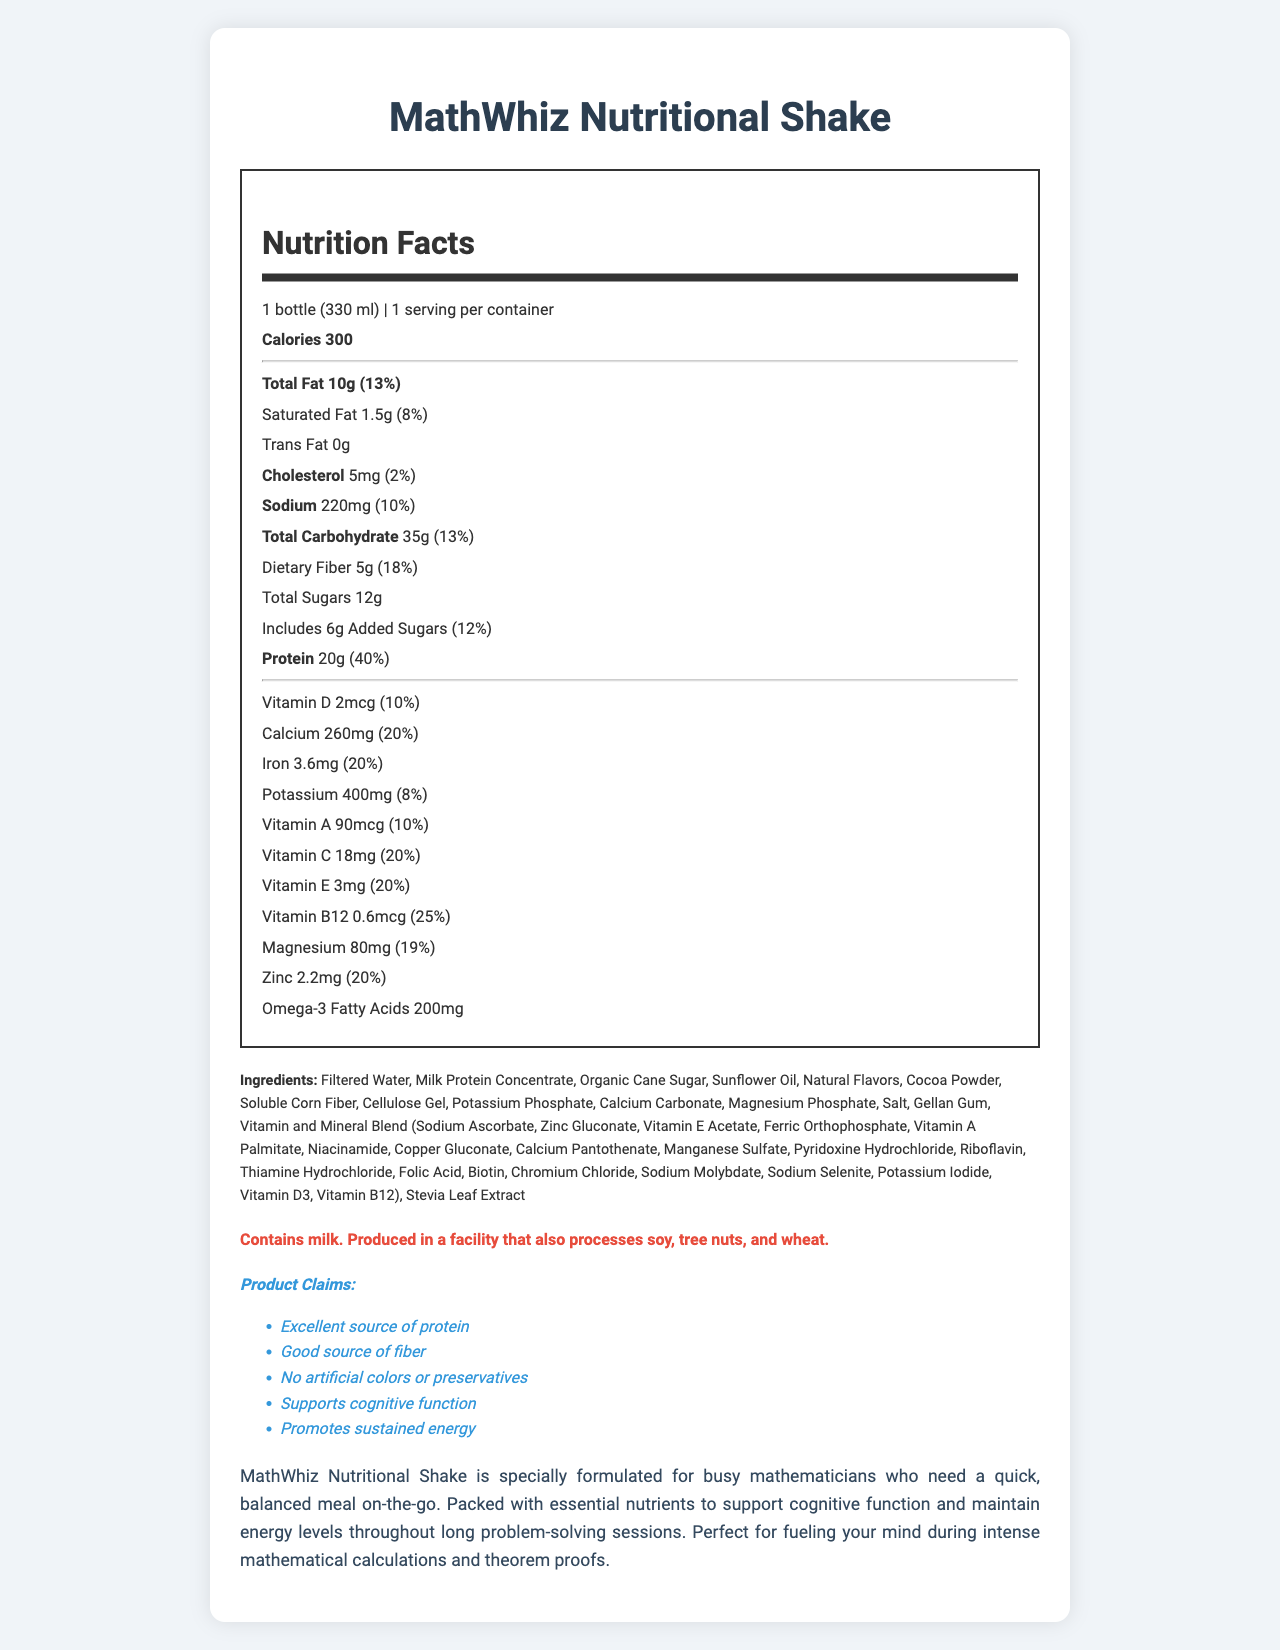what is the serving size of the MathWhiz Nutritional Shake? The serving size is clearly stated in the document as "1 bottle (330 ml)".
Answer: 1 bottle (330 ml) how many calories does one serving of MathWhiz Nutritional Shake contain? The document lists the calorie content as 300.
Answer: 300 what percentage of the daily value of dietary fiber is provided by one serving of the shake? The document states that dietary fiber is 5g, which is 18% of the daily value.
Answer: 18% list the main ingredients of the MathWhiz Nutritional Shake. The main ingredients are provided in the ingredients section of the document.
Answer: Filtered Water, Milk Protein Concentrate, Organic Cane Sugar, Sunflower Oil, Natural Flavors, Cocoa Powder, Soluble Corn Fiber, Cellulose Gel, Potassium Phosphate, Calcium Carbonate, Magnesium Phosphate, Salt, Gellan Gum, Vitamin and Mineral Blend, Stevia Leaf Extract what are the claims made about MathWhiz Nutritional Shake? The document lists these claims in the "Product Claims" section.
Answer: Excellent source of protein, Good source of fiber, No artificial colors or preservatives, Supports cognitive function, Promotes sustained energy which nutrient has the highest daily value percentage in one serving? A. Protein B. Iron C. Vitamin D D. Calcium Protein has the highest daily value percentage at 40%.
Answer: A what is the correct option for the amount of sodium in the MathWhiz Nutritional Shake compared to its daily value? i. 220mg (10%) ii. 220mg (20%) iii. 220mg (30%) iv. 220mg (15%) The amount of sodium is listed as 220mg and it represents 10% of the daily value, which matches option i.
Answer: i does the shake contain any artificial colors or preservatives? The document specifically states this claim: "No artificial colors or preservatives."
Answer: No is the MathWhiz Nutritional Shake suitable for people with lactose intolerance? The document mentions it contains milk but does not provide information specific to its suitability for lactose-intolerant individuals.
Answer: Cannot be determined summarize the main idea of the MathWhiz Nutritional Shake document The document gives a comprehensive overview of the nutritional profile and benefits of the MathWhiz Nutritional Shake, emphasizing its suitability for those needing a nutritious meal on-the-go.
Answer: The MathWhiz Nutritional Shake document provides detailed nutritional information about a meal replacement shake designed for busy mathematicians. It lists the serving size, calories, and the amounts and daily values of various nutrients such as fats, proteins, vitamins, and minerals. The shake is promoted as an excellent source of protein and fiber, supporting cognitive function and providing sustained energy. The ingredients and allergen information are also detailed, along with claims about the product's benefits. 